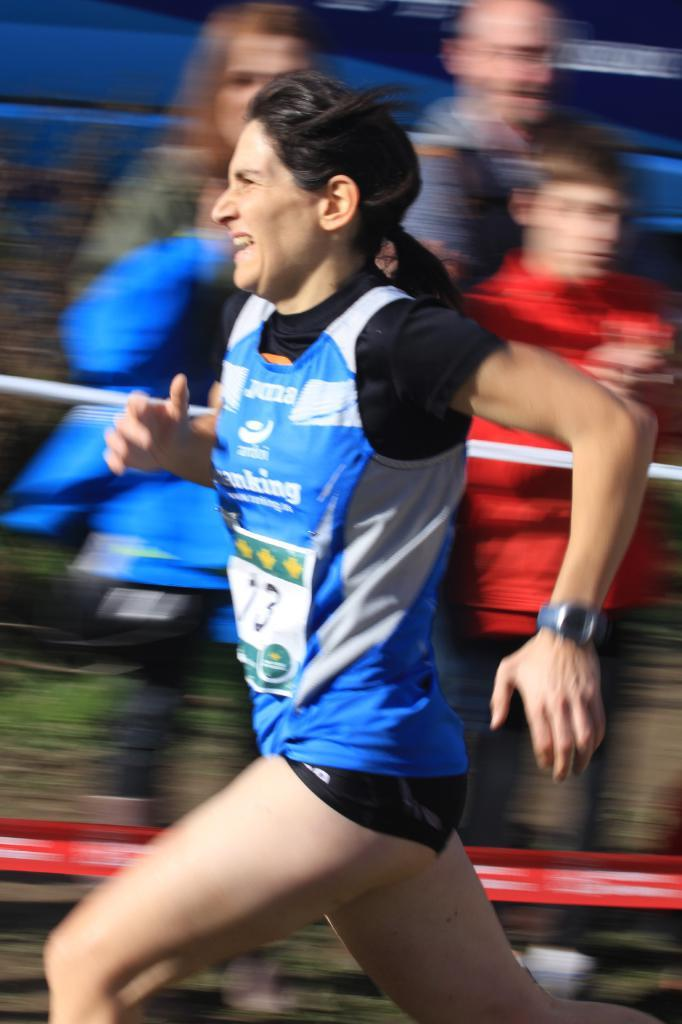Who is present in the image? There are people in the image. What is the woman in the image doing? A woman is running in the image. Can you describe the background of the image? The background of the image appears blurry. Where is the cushion placed on the sofa in the image? There is no cushion or sofa present in the image. How do the giants interact with the people in the image? There are no giants present in the image. 